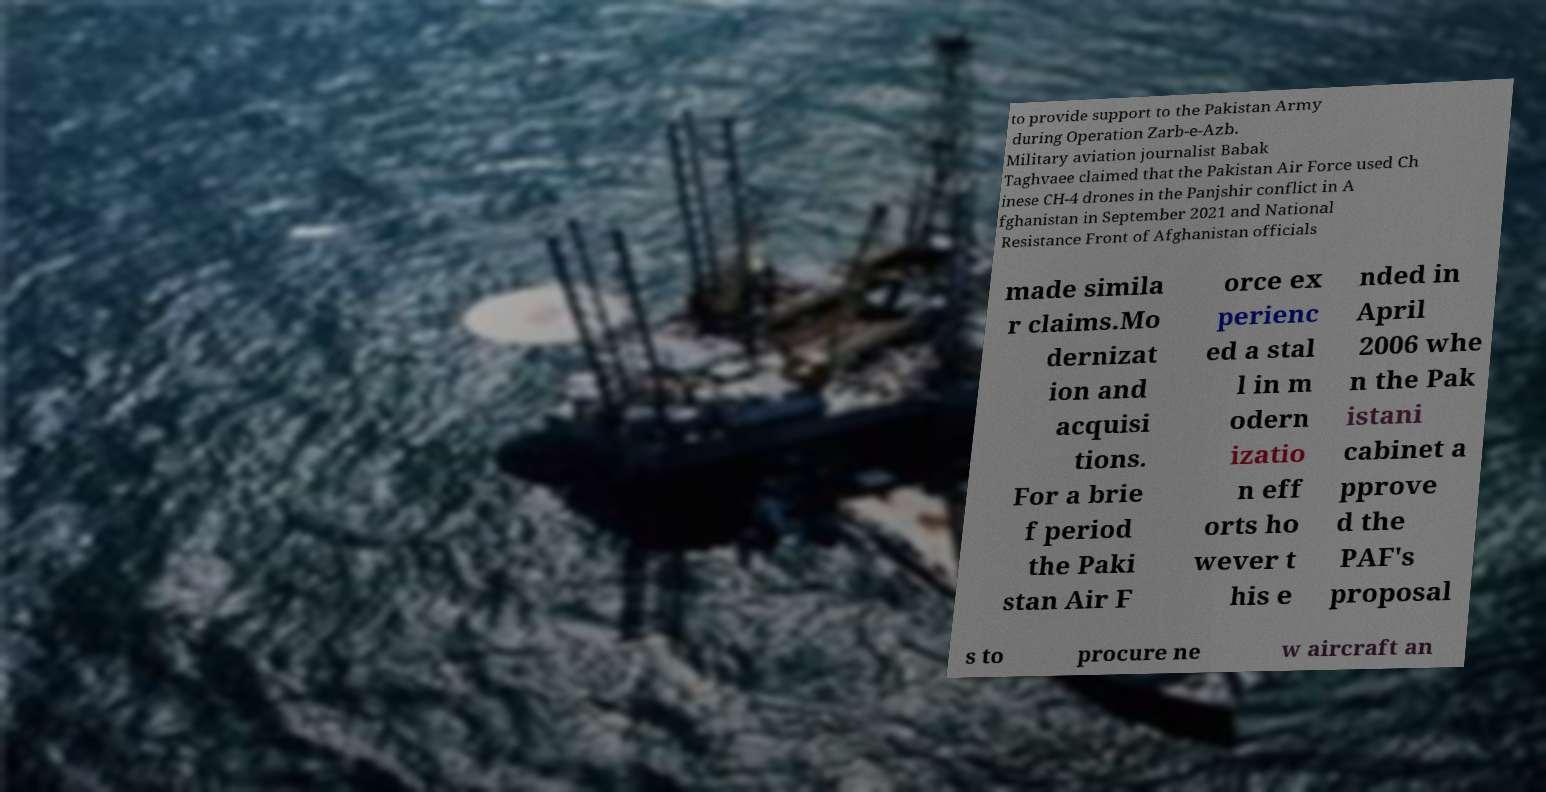Please identify and transcribe the text found in this image. to provide support to the Pakistan Army during Operation Zarb-e-Azb. Military aviation journalist Babak Taghvaee claimed that the Pakistan Air Force used Ch inese CH-4 drones in the Panjshir conflict in A fghanistan in September 2021 and National Resistance Front of Afghanistan officials made simila r claims.Mo dernizat ion and acquisi tions. For a brie f period the Paki stan Air F orce ex perienc ed a stal l in m odern izatio n eff orts ho wever t his e nded in April 2006 whe n the Pak istani cabinet a pprove d the PAF's proposal s to procure ne w aircraft an 